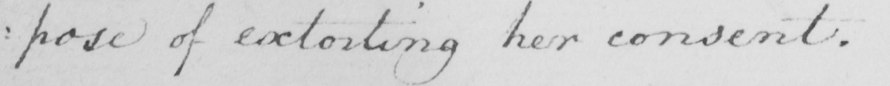Can you tell me what this handwritten text says? : pose of extorting her consent . 